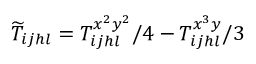Convert formula to latex. <formula><loc_0><loc_0><loc_500><loc_500>\widetilde { T } _ { i j h l } = T _ { i j h l } ^ { x ^ { 2 } y ^ { 2 } } / 4 - T _ { i j h l } ^ { x ^ { 3 } y } / 3</formula> 